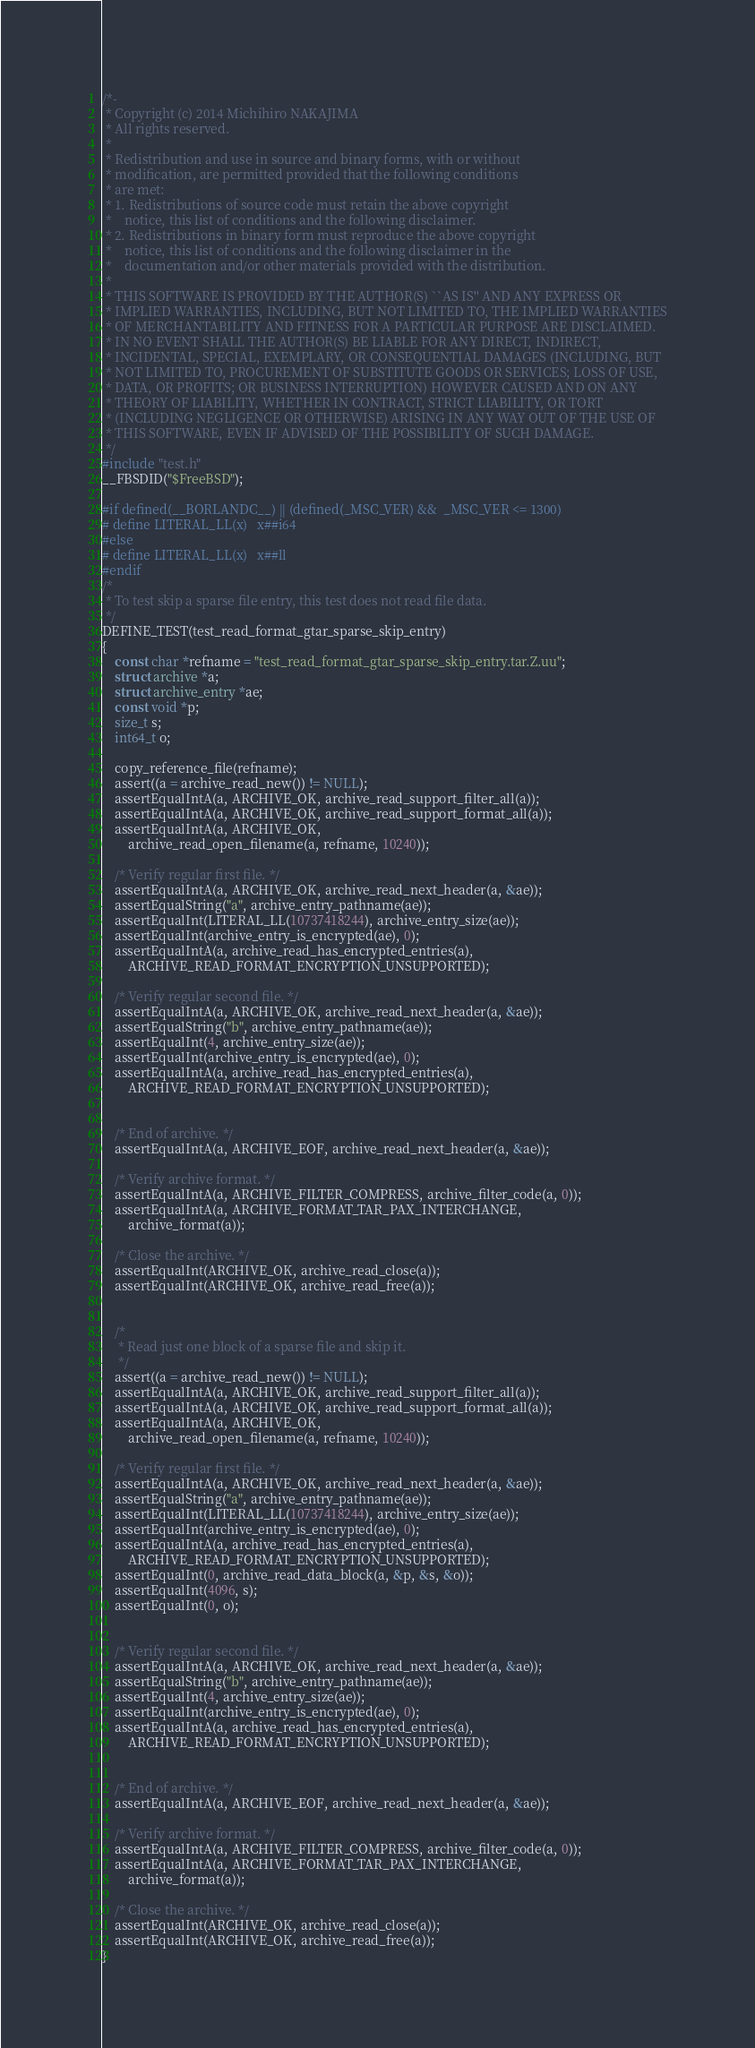Convert code to text. <code><loc_0><loc_0><loc_500><loc_500><_C_>/*-
 * Copyright (c) 2014 Michihiro NAKAJIMA
 * All rights reserved.
 *
 * Redistribution and use in source and binary forms, with or without
 * modification, are permitted provided that the following conditions
 * are met:
 * 1. Redistributions of source code must retain the above copyright
 *    notice, this list of conditions and the following disclaimer.
 * 2. Redistributions in binary form must reproduce the above copyright
 *    notice, this list of conditions and the following disclaimer in the
 *    documentation and/or other materials provided with the distribution.
 *
 * THIS SOFTWARE IS PROVIDED BY THE AUTHOR(S) ``AS IS'' AND ANY EXPRESS OR
 * IMPLIED WARRANTIES, INCLUDING, BUT NOT LIMITED TO, THE IMPLIED WARRANTIES
 * OF MERCHANTABILITY AND FITNESS FOR A PARTICULAR PURPOSE ARE DISCLAIMED.
 * IN NO EVENT SHALL THE AUTHOR(S) BE LIABLE FOR ANY DIRECT, INDIRECT,
 * INCIDENTAL, SPECIAL, EXEMPLARY, OR CONSEQUENTIAL DAMAGES (INCLUDING, BUT
 * NOT LIMITED TO, PROCUREMENT OF SUBSTITUTE GOODS OR SERVICES; LOSS OF USE,
 * DATA, OR PROFITS; OR BUSINESS INTERRUPTION) HOWEVER CAUSED AND ON ANY
 * THEORY OF LIABILITY, WHETHER IN CONTRACT, STRICT LIABILITY, OR TORT
 * (INCLUDING NEGLIGENCE OR OTHERWISE) ARISING IN ANY WAY OUT OF THE USE OF
 * THIS SOFTWARE, EVEN IF ADVISED OF THE POSSIBILITY OF SUCH DAMAGE.
 */
#include "test.h"
__FBSDID("$FreeBSD");

#if defined(__BORLANDC__) || (defined(_MSC_VER) &&  _MSC_VER <= 1300)
# define	LITERAL_LL(x)	x##i64
#else
# define	LITERAL_LL(x)	x##ll
#endif
/*
 * To test skip a sparse file entry, this test does not read file data.
 */
DEFINE_TEST(test_read_format_gtar_sparse_skip_entry)
{
	const char *refname = "test_read_format_gtar_sparse_skip_entry.tar.Z.uu";
	struct archive *a;
	struct archive_entry *ae;
	const void *p;
	size_t s;
	int64_t o;

	copy_reference_file(refname);
	assert((a = archive_read_new()) != NULL);
	assertEqualIntA(a, ARCHIVE_OK, archive_read_support_filter_all(a));
	assertEqualIntA(a, ARCHIVE_OK, archive_read_support_format_all(a));
	assertEqualIntA(a, ARCHIVE_OK,
	    archive_read_open_filename(a, refname, 10240));

	/* Verify regular first file. */
	assertEqualIntA(a, ARCHIVE_OK, archive_read_next_header(a, &ae));
	assertEqualString("a", archive_entry_pathname(ae));
	assertEqualInt(LITERAL_LL(10737418244), archive_entry_size(ae));
	assertEqualInt(archive_entry_is_encrypted(ae), 0);
	assertEqualIntA(a, archive_read_has_encrypted_entries(a),
	    ARCHIVE_READ_FORMAT_ENCRYPTION_UNSUPPORTED);

	/* Verify regular second file. */
	assertEqualIntA(a, ARCHIVE_OK, archive_read_next_header(a, &ae));
	assertEqualString("b", archive_entry_pathname(ae));
	assertEqualInt(4, archive_entry_size(ae));
	assertEqualInt(archive_entry_is_encrypted(ae), 0);
	assertEqualIntA(a, archive_read_has_encrypted_entries(a),
	    ARCHIVE_READ_FORMAT_ENCRYPTION_UNSUPPORTED);


	/* End of archive. */
	assertEqualIntA(a, ARCHIVE_EOF, archive_read_next_header(a, &ae));

	/* Verify archive format. */
	assertEqualIntA(a, ARCHIVE_FILTER_COMPRESS, archive_filter_code(a, 0));
	assertEqualIntA(a, ARCHIVE_FORMAT_TAR_PAX_INTERCHANGE,
	    archive_format(a));

	/* Close the archive. */
	assertEqualInt(ARCHIVE_OK, archive_read_close(a));
	assertEqualInt(ARCHIVE_OK, archive_read_free(a));


	/*
	 * Read just one block of a sparse file and skip it.
	 */
	assert((a = archive_read_new()) != NULL);
	assertEqualIntA(a, ARCHIVE_OK, archive_read_support_filter_all(a));
	assertEqualIntA(a, ARCHIVE_OK, archive_read_support_format_all(a));
	assertEqualIntA(a, ARCHIVE_OK,
	    archive_read_open_filename(a, refname, 10240));

	/* Verify regular first file. */
	assertEqualIntA(a, ARCHIVE_OK, archive_read_next_header(a, &ae));
	assertEqualString("a", archive_entry_pathname(ae));
	assertEqualInt(LITERAL_LL(10737418244), archive_entry_size(ae));
	assertEqualInt(archive_entry_is_encrypted(ae), 0);
	assertEqualIntA(a, archive_read_has_encrypted_entries(a),
	    ARCHIVE_READ_FORMAT_ENCRYPTION_UNSUPPORTED);
	assertEqualInt(0, archive_read_data_block(a, &p, &s, &o));
	assertEqualInt(4096, s);
	assertEqualInt(0, o);


	/* Verify regular second file. */
	assertEqualIntA(a, ARCHIVE_OK, archive_read_next_header(a, &ae));
	assertEqualString("b", archive_entry_pathname(ae));
	assertEqualInt(4, archive_entry_size(ae));
	assertEqualInt(archive_entry_is_encrypted(ae), 0);
	assertEqualIntA(a, archive_read_has_encrypted_entries(a),
	    ARCHIVE_READ_FORMAT_ENCRYPTION_UNSUPPORTED);


	/* End of archive. */
	assertEqualIntA(a, ARCHIVE_EOF, archive_read_next_header(a, &ae));

	/* Verify archive format. */
	assertEqualIntA(a, ARCHIVE_FILTER_COMPRESS, archive_filter_code(a, 0));
	assertEqualIntA(a, ARCHIVE_FORMAT_TAR_PAX_INTERCHANGE,
	    archive_format(a));

	/* Close the archive. */
	assertEqualInt(ARCHIVE_OK, archive_read_close(a));
	assertEqualInt(ARCHIVE_OK, archive_read_free(a));
}

</code> 